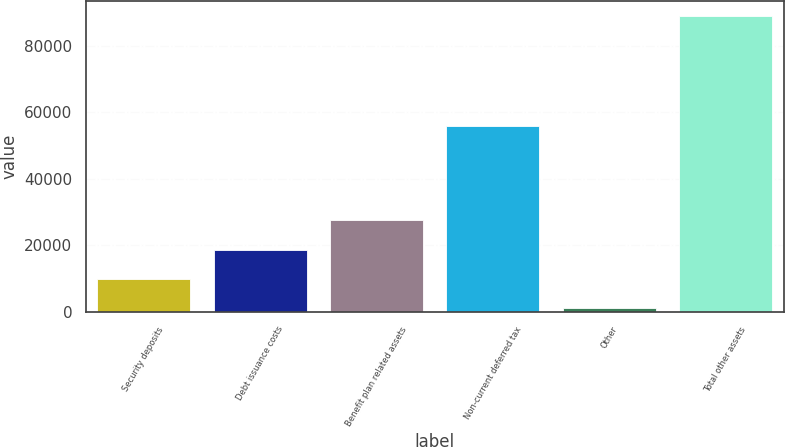<chart> <loc_0><loc_0><loc_500><loc_500><bar_chart><fcel>Security deposits<fcel>Debt issuance costs<fcel>Benefit plan related assets<fcel>Non-current deferred tax<fcel>Other<fcel>Total other assets<nl><fcel>9967.2<fcel>18753.4<fcel>27539.6<fcel>55845<fcel>1181<fcel>89043<nl></chart> 